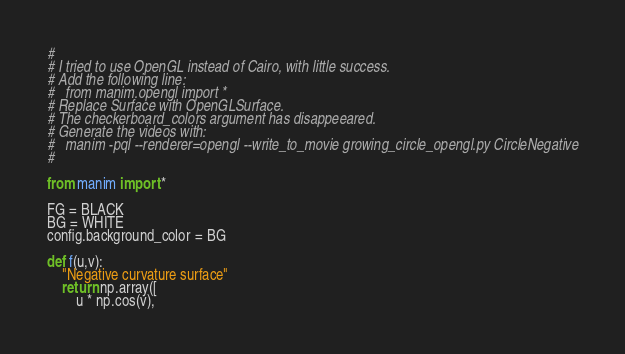Convert code to text. <code><loc_0><loc_0><loc_500><loc_500><_Python_>#
# I tried to use OpenGL instead of Cairo, with little success.
# Add the following line: 
#   from manim.opengl import *
# Replace Surface with OpenGLSurface.
# The checkerboard_colors argument has disappeeared.
# Generate the videos with:
#   manim -pql --renderer=opengl --write_to_movie growing_circle_opengl.py CircleNegative
# 

from manim import *

FG = BLACK
BG = WHITE
config.background_color = BG

def f(u,v):
    "Negative curvature surface"
    return np.array([
        u * np.cos(v),</code> 